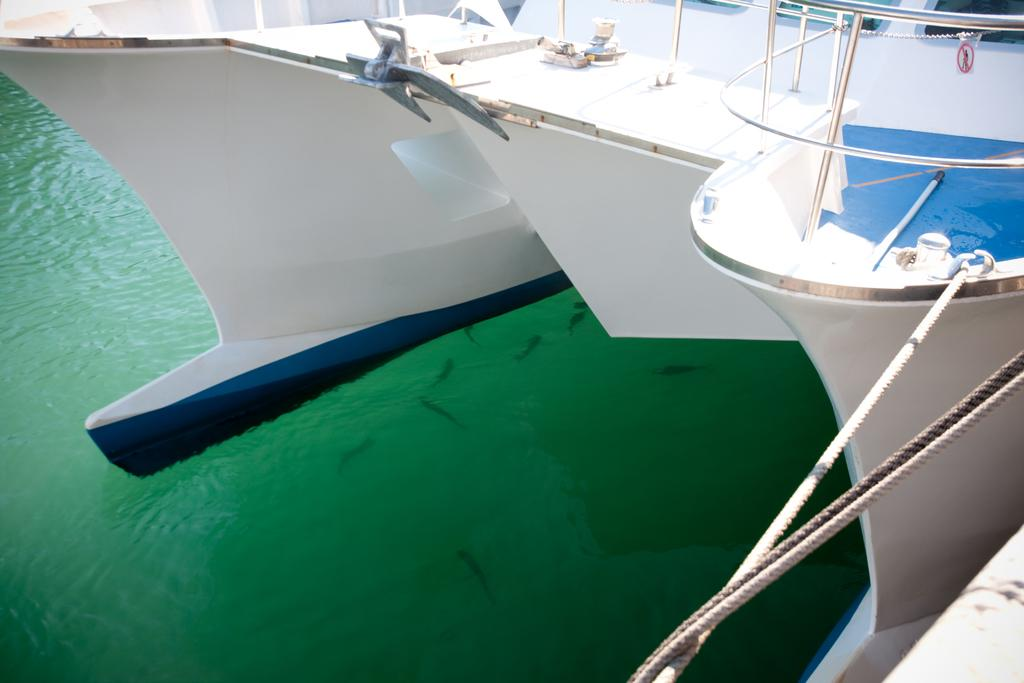What is the main subject of the image? The main subject of the image is a ship. What can be seen tied to the ship in the image? There are ropes tied to the ship in the image. What is visible in the water in the image? There are fishes in the water in the image. What type of machine is being used to increase the profit in the image? There is no machine or mention of profit in the image; it features a ship with ropes tied to it and fishes in the water. What are the people on the ship talking about in the image? There are no people visible on the ship in the image. 